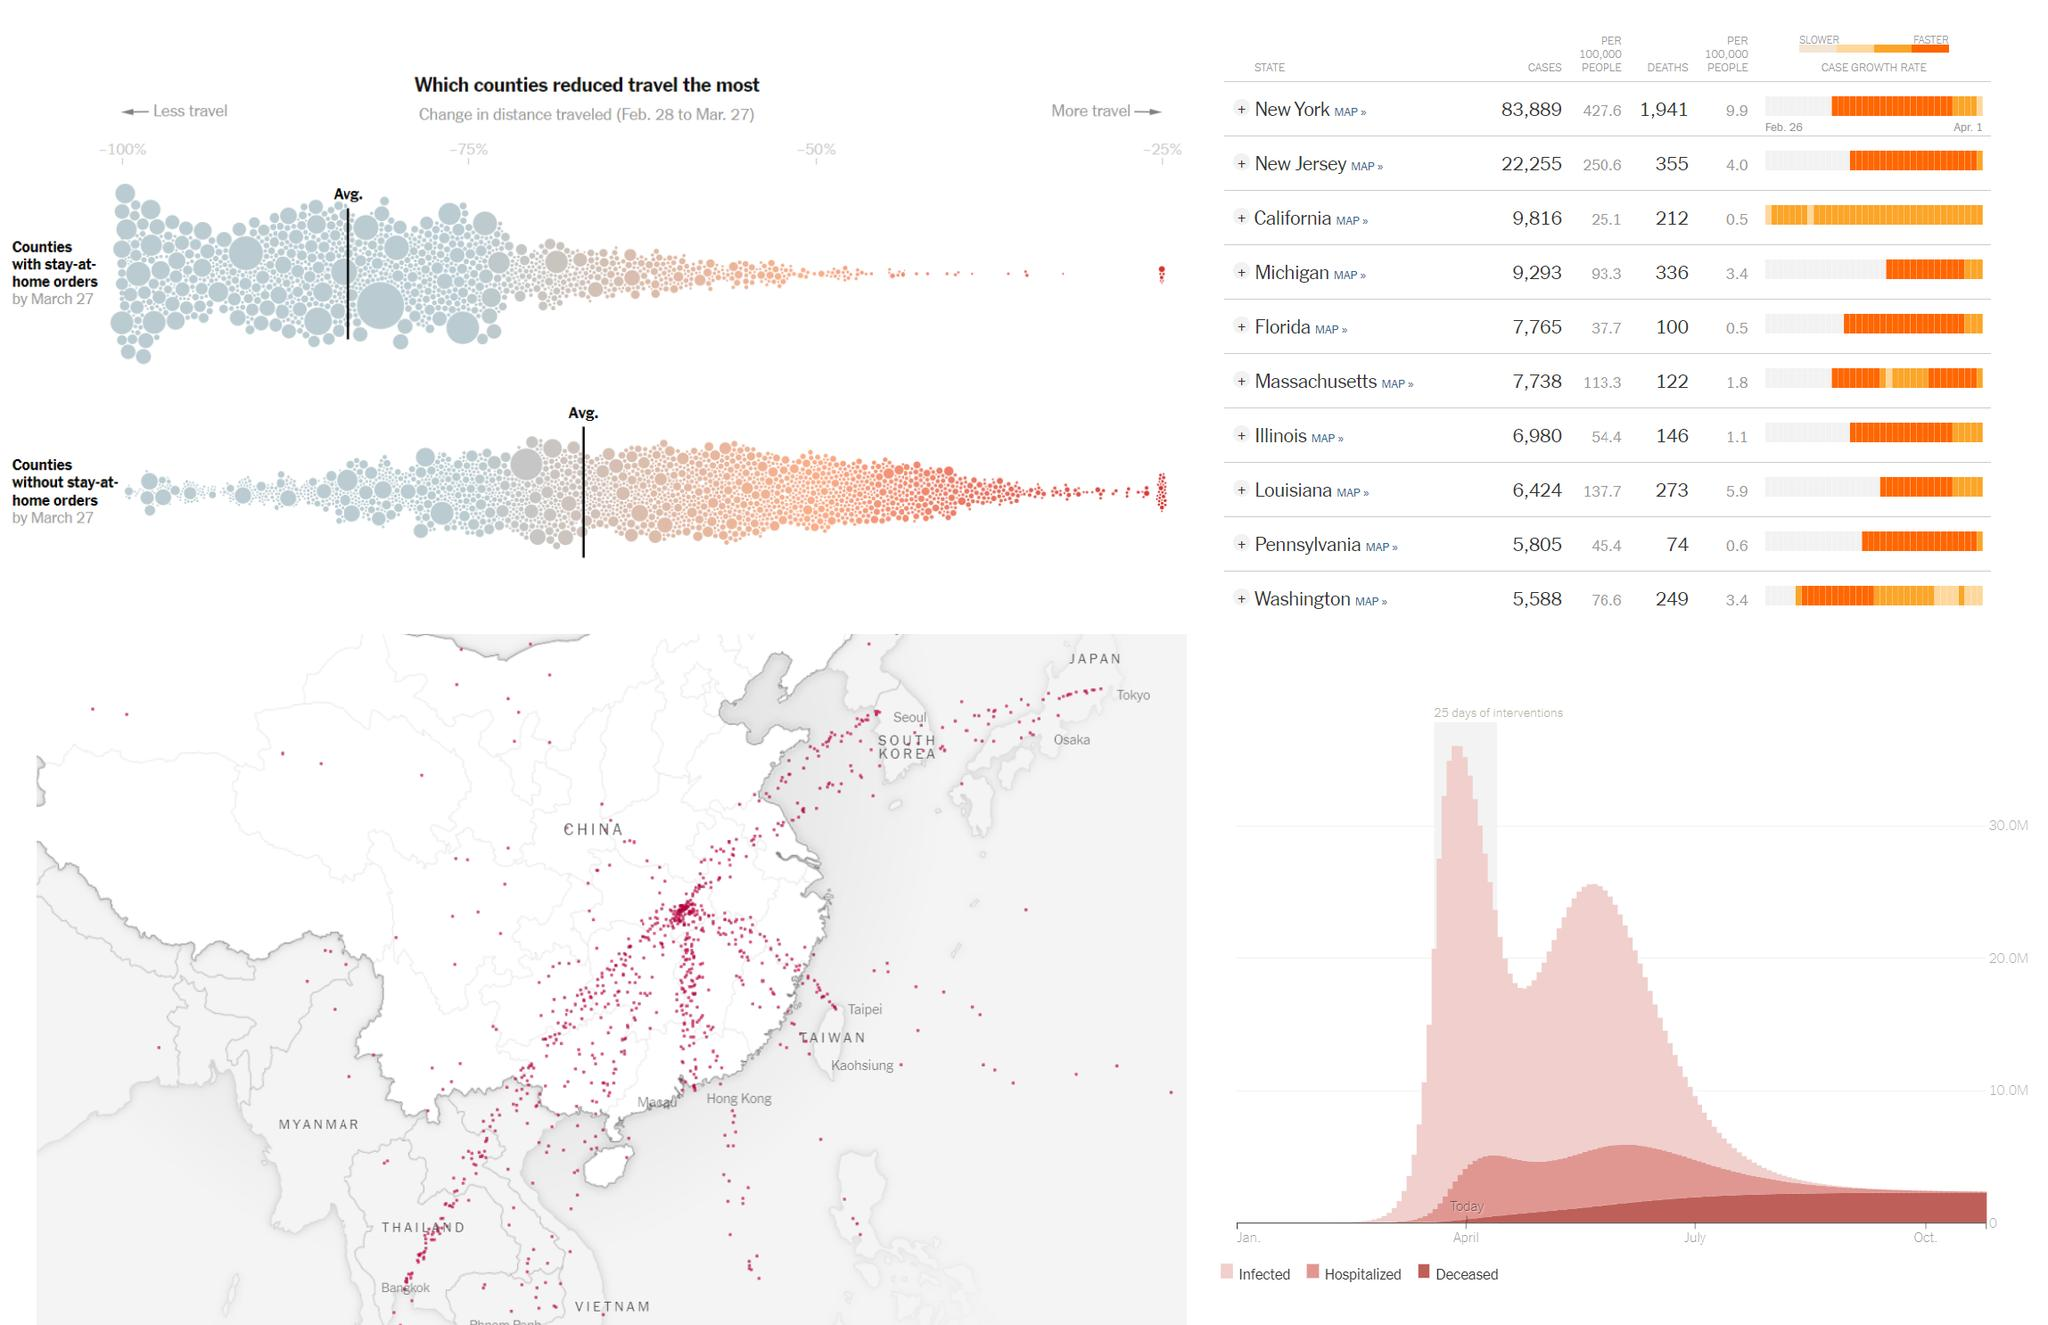Outline some significant characteristics in this image. According to the given information, the state with the highest number of deaths per 100,000 people is New York. New Jersey ranks third in terms of the number of deaths per 100,000 people. The state with the fifth highest number of cases from February 28 to March 27 is Florida. According to the data provided, Louisiana had the eighth highest number of cases from February 28 to March 27. According to the given information, Michigan has the fifth highest number of cases per 100,000 people out of all the states. 